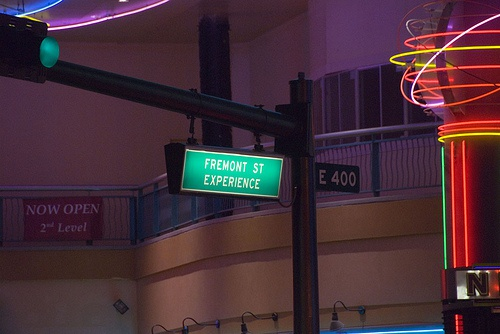Describe the objects in this image and their specific colors. I can see a traffic light in purple, black, and teal tones in this image. 